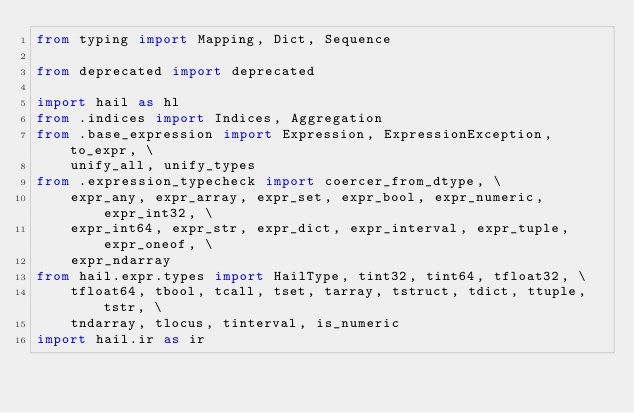<code> <loc_0><loc_0><loc_500><loc_500><_Python_>from typing import Mapping, Dict, Sequence

from deprecated import deprecated

import hail as hl
from .indices import Indices, Aggregation
from .base_expression import Expression, ExpressionException, to_expr, \
    unify_all, unify_types
from .expression_typecheck import coercer_from_dtype, \
    expr_any, expr_array, expr_set, expr_bool, expr_numeric, expr_int32, \
    expr_int64, expr_str, expr_dict, expr_interval, expr_tuple, expr_oneof, \
    expr_ndarray
from hail.expr.types import HailType, tint32, tint64, tfloat32, \
    tfloat64, tbool, tcall, tset, tarray, tstruct, tdict, ttuple, tstr, \
    tndarray, tlocus, tinterval, is_numeric
import hail.ir as ir</code> 